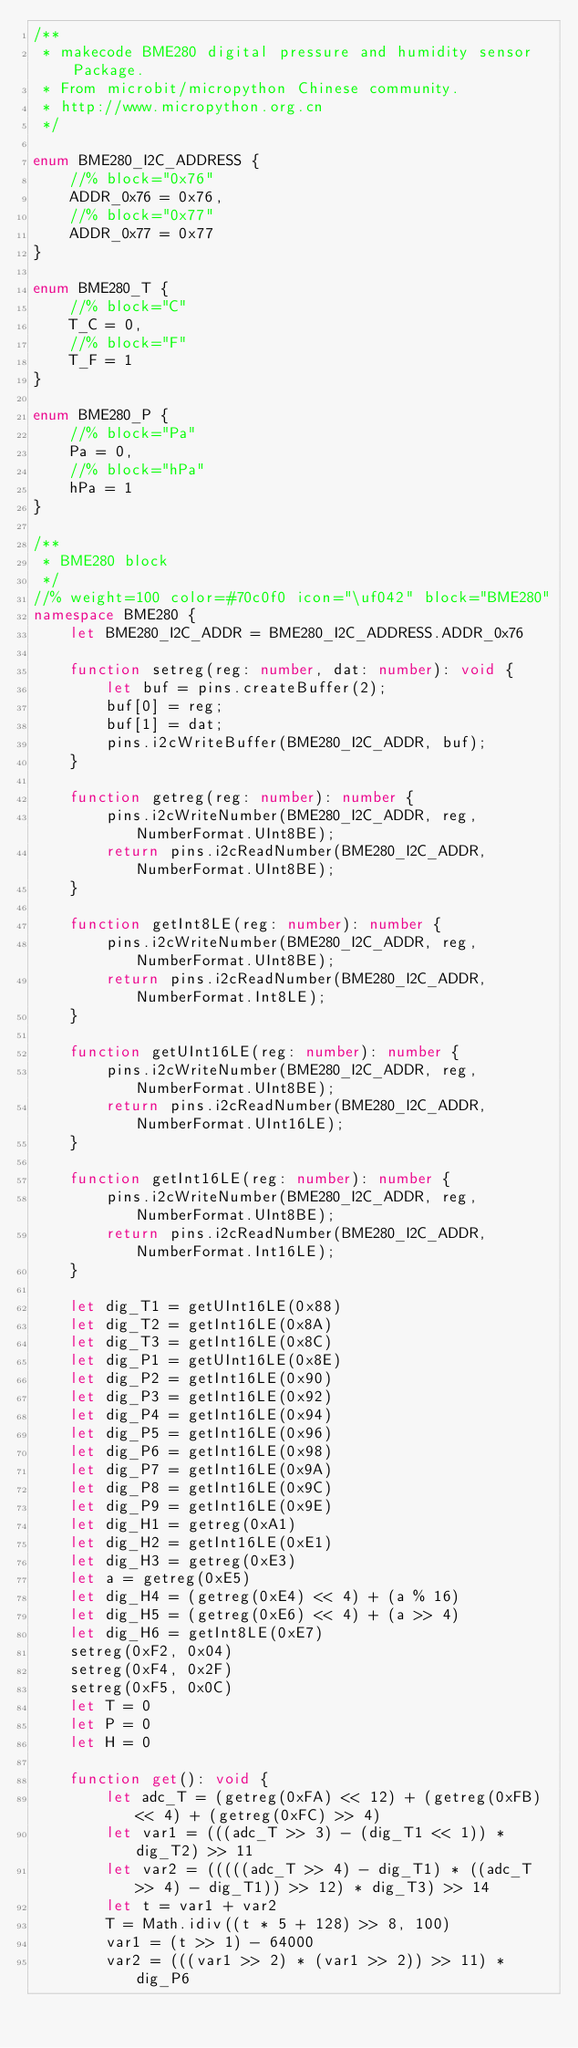<code> <loc_0><loc_0><loc_500><loc_500><_TypeScript_>/**
 * makecode BME280 digital pressure and humidity sensor Package.
 * From microbit/micropython Chinese community.
 * http://www.micropython.org.cn
 */

enum BME280_I2C_ADDRESS {
    //% block="0x76"
    ADDR_0x76 = 0x76,
    //% block="0x77"
    ADDR_0x77 = 0x77
}

enum BME280_T {
    //% block="C"
    T_C = 0,
    //% block="F"
    T_F = 1
}

enum BME280_P {
    //% block="Pa"
    Pa = 0,
    //% block="hPa"
    hPa = 1
}

/**
 * BME280 block
 */
//% weight=100 color=#70c0f0 icon="\uf042" block="BME280"
namespace BME280 {
    let BME280_I2C_ADDR = BME280_I2C_ADDRESS.ADDR_0x76

    function setreg(reg: number, dat: number): void {
        let buf = pins.createBuffer(2);
        buf[0] = reg;
        buf[1] = dat;
        pins.i2cWriteBuffer(BME280_I2C_ADDR, buf);
    }

    function getreg(reg: number): number {
        pins.i2cWriteNumber(BME280_I2C_ADDR, reg, NumberFormat.UInt8BE);
        return pins.i2cReadNumber(BME280_I2C_ADDR, NumberFormat.UInt8BE);
    }

    function getInt8LE(reg: number): number {
        pins.i2cWriteNumber(BME280_I2C_ADDR, reg, NumberFormat.UInt8BE);
        return pins.i2cReadNumber(BME280_I2C_ADDR, NumberFormat.Int8LE);
    }

    function getUInt16LE(reg: number): number {
        pins.i2cWriteNumber(BME280_I2C_ADDR, reg, NumberFormat.UInt8BE);
        return pins.i2cReadNumber(BME280_I2C_ADDR, NumberFormat.UInt16LE);
    }

    function getInt16LE(reg: number): number {
        pins.i2cWriteNumber(BME280_I2C_ADDR, reg, NumberFormat.UInt8BE);
        return pins.i2cReadNumber(BME280_I2C_ADDR, NumberFormat.Int16LE);
    }

    let dig_T1 = getUInt16LE(0x88)
    let dig_T2 = getInt16LE(0x8A)
    let dig_T3 = getInt16LE(0x8C)
    let dig_P1 = getUInt16LE(0x8E)
    let dig_P2 = getInt16LE(0x90)
    let dig_P3 = getInt16LE(0x92)
    let dig_P4 = getInt16LE(0x94)
    let dig_P5 = getInt16LE(0x96)
    let dig_P6 = getInt16LE(0x98)
    let dig_P7 = getInt16LE(0x9A)
    let dig_P8 = getInt16LE(0x9C)
    let dig_P9 = getInt16LE(0x9E)
    let dig_H1 = getreg(0xA1)
    let dig_H2 = getInt16LE(0xE1)
    let dig_H3 = getreg(0xE3)
    let a = getreg(0xE5)
    let dig_H4 = (getreg(0xE4) << 4) + (a % 16)
    let dig_H5 = (getreg(0xE6) << 4) + (a >> 4)
    let dig_H6 = getInt8LE(0xE7)
    setreg(0xF2, 0x04)
    setreg(0xF4, 0x2F)
    setreg(0xF5, 0x0C)
    let T = 0
    let P = 0
    let H = 0

    function get(): void {
        let adc_T = (getreg(0xFA) << 12) + (getreg(0xFB) << 4) + (getreg(0xFC) >> 4)
        let var1 = (((adc_T >> 3) - (dig_T1 << 1)) * dig_T2) >> 11
        let var2 = (((((adc_T >> 4) - dig_T1) * ((adc_T >> 4) - dig_T1)) >> 12) * dig_T3) >> 14
        let t = var1 + var2
        T = Math.idiv((t * 5 + 128) >> 8, 100)
        var1 = (t >> 1) - 64000
        var2 = (((var1 >> 2) * (var1 >> 2)) >> 11) * dig_P6</code> 